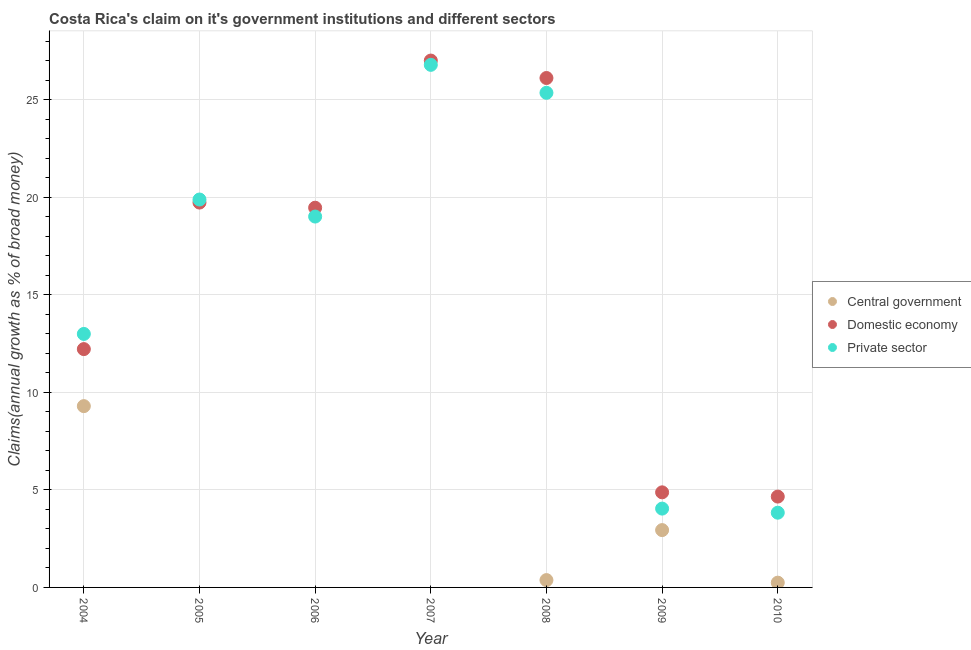How many different coloured dotlines are there?
Ensure brevity in your answer.  3. Is the number of dotlines equal to the number of legend labels?
Provide a succinct answer. No. Across all years, what is the maximum percentage of claim on the private sector?
Offer a terse response. 26.8. Across all years, what is the minimum percentage of claim on the private sector?
Keep it short and to the point. 3.83. What is the total percentage of claim on the central government in the graph?
Offer a very short reply. 12.86. What is the difference between the percentage of claim on the domestic economy in 2005 and that in 2010?
Provide a succinct answer. 15.08. What is the difference between the percentage of claim on the domestic economy in 2006 and the percentage of claim on the central government in 2009?
Provide a succinct answer. 16.53. What is the average percentage of claim on the central government per year?
Provide a succinct answer. 1.84. In the year 2004, what is the difference between the percentage of claim on the central government and percentage of claim on the private sector?
Offer a very short reply. -3.7. In how many years, is the percentage of claim on the domestic economy greater than 14 %?
Provide a succinct answer. 4. What is the ratio of the percentage of claim on the private sector in 2009 to that in 2010?
Give a very brief answer. 1.05. Is the percentage of claim on the domestic economy in 2008 less than that in 2009?
Offer a terse response. No. Is the difference between the percentage of claim on the private sector in 2004 and 2009 greater than the difference between the percentage of claim on the central government in 2004 and 2009?
Your response must be concise. Yes. What is the difference between the highest and the second highest percentage of claim on the private sector?
Give a very brief answer. 1.43. What is the difference between the highest and the lowest percentage of claim on the domestic economy?
Keep it short and to the point. 22.36. In how many years, is the percentage of claim on the private sector greater than the average percentage of claim on the private sector taken over all years?
Make the answer very short. 4. Is the sum of the percentage of claim on the central government in 2008 and 2010 greater than the maximum percentage of claim on the domestic economy across all years?
Ensure brevity in your answer.  No. Is the percentage of claim on the private sector strictly less than the percentage of claim on the domestic economy over the years?
Provide a succinct answer. No. Are the values on the major ticks of Y-axis written in scientific E-notation?
Your answer should be very brief. No. Does the graph contain any zero values?
Your response must be concise. Yes. Where does the legend appear in the graph?
Give a very brief answer. Center right. What is the title of the graph?
Provide a succinct answer. Costa Rica's claim on it's government institutions and different sectors. Does "Fuel" appear as one of the legend labels in the graph?
Your response must be concise. No. What is the label or title of the X-axis?
Your answer should be compact. Year. What is the label or title of the Y-axis?
Ensure brevity in your answer.  Claims(annual growth as % of broad money). What is the Claims(annual growth as % of broad money) of Central government in 2004?
Ensure brevity in your answer.  9.3. What is the Claims(annual growth as % of broad money) in Domestic economy in 2004?
Your response must be concise. 12.22. What is the Claims(annual growth as % of broad money) of Private sector in 2004?
Make the answer very short. 13. What is the Claims(annual growth as % of broad money) in Central government in 2005?
Make the answer very short. 0. What is the Claims(annual growth as % of broad money) in Domestic economy in 2005?
Your response must be concise. 19.73. What is the Claims(annual growth as % of broad money) of Private sector in 2005?
Keep it short and to the point. 19.89. What is the Claims(annual growth as % of broad money) in Domestic economy in 2006?
Provide a succinct answer. 19.47. What is the Claims(annual growth as % of broad money) in Private sector in 2006?
Keep it short and to the point. 19.02. What is the Claims(annual growth as % of broad money) of Central government in 2007?
Provide a succinct answer. 0. What is the Claims(annual growth as % of broad money) in Domestic economy in 2007?
Provide a succinct answer. 27.02. What is the Claims(annual growth as % of broad money) of Private sector in 2007?
Keep it short and to the point. 26.8. What is the Claims(annual growth as % of broad money) of Central government in 2008?
Keep it short and to the point. 0.38. What is the Claims(annual growth as % of broad money) in Domestic economy in 2008?
Your answer should be compact. 26.12. What is the Claims(annual growth as % of broad money) in Private sector in 2008?
Your response must be concise. 25.36. What is the Claims(annual growth as % of broad money) in Central government in 2009?
Keep it short and to the point. 2.94. What is the Claims(annual growth as % of broad money) of Domestic economy in 2009?
Offer a very short reply. 4.88. What is the Claims(annual growth as % of broad money) of Private sector in 2009?
Offer a very short reply. 4.04. What is the Claims(annual growth as % of broad money) of Central government in 2010?
Offer a terse response. 0.24. What is the Claims(annual growth as % of broad money) in Domestic economy in 2010?
Your answer should be very brief. 4.66. What is the Claims(annual growth as % of broad money) of Private sector in 2010?
Give a very brief answer. 3.83. Across all years, what is the maximum Claims(annual growth as % of broad money) of Central government?
Keep it short and to the point. 9.3. Across all years, what is the maximum Claims(annual growth as % of broad money) in Domestic economy?
Keep it short and to the point. 27.02. Across all years, what is the maximum Claims(annual growth as % of broad money) of Private sector?
Offer a very short reply. 26.8. Across all years, what is the minimum Claims(annual growth as % of broad money) in Domestic economy?
Your answer should be very brief. 4.66. Across all years, what is the minimum Claims(annual growth as % of broad money) in Private sector?
Provide a succinct answer. 3.83. What is the total Claims(annual growth as % of broad money) of Central government in the graph?
Your answer should be very brief. 12.86. What is the total Claims(annual growth as % of broad money) of Domestic economy in the graph?
Offer a very short reply. 114.09. What is the total Claims(annual growth as % of broad money) of Private sector in the graph?
Offer a terse response. 111.94. What is the difference between the Claims(annual growth as % of broad money) of Domestic economy in 2004 and that in 2005?
Make the answer very short. -7.51. What is the difference between the Claims(annual growth as % of broad money) of Private sector in 2004 and that in 2005?
Provide a succinct answer. -6.89. What is the difference between the Claims(annual growth as % of broad money) of Domestic economy in 2004 and that in 2006?
Offer a very short reply. -7.25. What is the difference between the Claims(annual growth as % of broad money) of Private sector in 2004 and that in 2006?
Offer a very short reply. -6.02. What is the difference between the Claims(annual growth as % of broad money) in Domestic economy in 2004 and that in 2007?
Your answer should be very brief. -14.8. What is the difference between the Claims(annual growth as % of broad money) in Private sector in 2004 and that in 2007?
Ensure brevity in your answer.  -13.8. What is the difference between the Claims(annual growth as % of broad money) of Central government in 2004 and that in 2008?
Offer a terse response. 8.92. What is the difference between the Claims(annual growth as % of broad money) in Domestic economy in 2004 and that in 2008?
Offer a very short reply. -13.9. What is the difference between the Claims(annual growth as % of broad money) in Private sector in 2004 and that in 2008?
Make the answer very short. -12.36. What is the difference between the Claims(annual growth as % of broad money) in Central government in 2004 and that in 2009?
Your answer should be very brief. 6.36. What is the difference between the Claims(annual growth as % of broad money) in Domestic economy in 2004 and that in 2009?
Give a very brief answer. 7.34. What is the difference between the Claims(annual growth as % of broad money) in Private sector in 2004 and that in 2009?
Provide a short and direct response. 8.96. What is the difference between the Claims(annual growth as % of broad money) in Central government in 2004 and that in 2010?
Your answer should be very brief. 9.05. What is the difference between the Claims(annual growth as % of broad money) of Domestic economy in 2004 and that in 2010?
Give a very brief answer. 7.56. What is the difference between the Claims(annual growth as % of broad money) of Private sector in 2004 and that in 2010?
Ensure brevity in your answer.  9.17. What is the difference between the Claims(annual growth as % of broad money) of Domestic economy in 2005 and that in 2006?
Provide a short and direct response. 0.26. What is the difference between the Claims(annual growth as % of broad money) of Private sector in 2005 and that in 2006?
Provide a succinct answer. 0.87. What is the difference between the Claims(annual growth as % of broad money) of Domestic economy in 2005 and that in 2007?
Offer a very short reply. -7.28. What is the difference between the Claims(annual growth as % of broad money) in Private sector in 2005 and that in 2007?
Offer a very short reply. -6.9. What is the difference between the Claims(annual growth as % of broad money) in Domestic economy in 2005 and that in 2008?
Offer a terse response. -6.39. What is the difference between the Claims(annual growth as % of broad money) of Private sector in 2005 and that in 2008?
Your answer should be very brief. -5.47. What is the difference between the Claims(annual growth as % of broad money) of Domestic economy in 2005 and that in 2009?
Give a very brief answer. 14.86. What is the difference between the Claims(annual growth as % of broad money) of Private sector in 2005 and that in 2009?
Make the answer very short. 15.85. What is the difference between the Claims(annual growth as % of broad money) in Domestic economy in 2005 and that in 2010?
Keep it short and to the point. 15.08. What is the difference between the Claims(annual growth as % of broad money) of Private sector in 2005 and that in 2010?
Ensure brevity in your answer.  16.06. What is the difference between the Claims(annual growth as % of broad money) of Domestic economy in 2006 and that in 2007?
Offer a very short reply. -7.55. What is the difference between the Claims(annual growth as % of broad money) in Private sector in 2006 and that in 2007?
Offer a very short reply. -7.78. What is the difference between the Claims(annual growth as % of broad money) of Domestic economy in 2006 and that in 2008?
Give a very brief answer. -6.65. What is the difference between the Claims(annual growth as % of broad money) of Private sector in 2006 and that in 2008?
Give a very brief answer. -6.34. What is the difference between the Claims(annual growth as % of broad money) in Domestic economy in 2006 and that in 2009?
Your answer should be very brief. 14.59. What is the difference between the Claims(annual growth as % of broad money) in Private sector in 2006 and that in 2009?
Your response must be concise. 14.97. What is the difference between the Claims(annual growth as % of broad money) of Domestic economy in 2006 and that in 2010?
Provide a succinct answer. 14.81. What is the difference between the Claims(annual growth as % of broad money) in Private sector in 2006 and that in 2010?
Keep it short and to the point. 15.18. What is the difference between the Claims(annual growth as % of broad money) in Domestic economy in 2007 and that in 2008?
Make the answer very short. 0.89. What is the difference between the Claims(annual growth as % of broad money) in Private sector in 2007 and that in 2008?
Keep it short and to the point. 1.43. What is the difference between the Claims(annual growth as % of broad money) of Domestic economy in 2007 and that in 2009?
Offer a terse response. 22.14. What is the difference between the Claims(annual growth as % of broad money) in Private sector in 2007 and that in 2009?
Keep it short and to the point. 22.75. What is the difference between the Claims(annual growth as % of broad money) of Domestic economy in 2007 and that in 2010?
Make the answer very short. 22.36. What is the difference between the Claims(annual growth as % of broad money) in Private sector in 2007 and that in 2010?
Keep it short and to the point. 22.96. What is the difference between the Claims(annual growth as % of broad money) of Central government in 2008 and that in 2009?
Ensure brevity in your answer.  -2.56. What is the difference between the Claims(annual growth as % of broad money) in Domestic economy in 2008 and that in 2009?
Keep it short and to the point. 21.25. What is the difference between the Claims(annual growth as % of broad money) of Private sector in 2008 and that in 2009?
Your answer should be very brief. 21.32. What is the difference between the Claims(annual growth as % of broad money) of Central government in 2008 and that in 2010?
Offer a very short reply. 0.13. What is the difference between the Claims(annual growth as % of broad money) of Domestic economy in 2008 and that in 2010?
Your response must be concise. 21.46. What is the difference between the Claims(annual growth as % of broad money) of Private sector in 2008 and that in 2010?
Offer a very short reply. 21.53. What is the difference between the Claims(annual growth as % of broad money) of Central government in 2009 and that in 2010?
Give a very brief answer. 2.7. What is the difference between the Claims(annual growth as % of broad money) of Domestic economy in 2009 and that in 2010?
Provide a short and direct response. 0.22. What is the difference between the Claims(annual growth as % of broad money) of Private sector in 2009 and that in 2010?
Your answer should be compact. 0.21. What is the difference between the Claims(annual growth as % of broad money) in Central government in 2004 and the Claims(annual growth as % of broad money) in Domestic economy in 2005?
Your answer should be very brief. -10.44. What is the difference between the Claims(annual growth as % of broad money) in Central government in 2004 and the Claims(annual growth as % of broad money) in Private sector in 2005?
Keep it short and to the point. -10.59. What is the difference between the Claims(annual growth as % of broad money) of Domestic economy in 2004 and the Claims(annual growth as % of broad money) of Private sector in 2005?
Keep it short and to the point. -7.67. What is the difference between the Claims(annual growth as % of broad money) of Central government in 2004 and the Claims(annual growth as % of broad money) of Domestic economy in 2006?
Give a very brief answer. -10.17. What is the difference between the Claims(annual growth as % of broad money) in Central government in 2004 and the Claims(annual growth as % of broad money) in Private sector in 2006?
Offer a very short reply. -9.72. What is the difference between the Claims(annual growth as % of broad money) of Domestic economy in 2004 and the Claims(annual growth as % of broad money) of Private sector in 2006?
Offer a very short reply. -6.8. What is the difference between the Claims(annual growth as % of broad money) in Central government in 2004 and the Claims(annual growth as % of broad money) in Domestic economy in 2007?
Make the answer very short. -17.72. What is the difference between the Claims(annual growth as % of broad money) in Central government in 2004 and the Claims(annual growth as % of broad money) in Private sector in 2007?
Your answer should be compact. -17.5. What is the difference between the Claims(annual growth as % of broad money) in Domestic economy in 2004 and the Claims(annual growth as % of broad money) in Private sector in 2007?
Keep it short and to the point. -14.58. What is the difference between the Claims(annual growth as % of broad money) in Central government in 2004 and the Claims(annual growth as % of broad money) in Domestic economy in 2008?
Provide a succinct answer. -16.82. What is the difference between the Claims(annual growth as % of broad money) of Central government in 2004 and the Claims(annual growth as % of broad money) of Private sector in 2008?
Your answer should be very brief. -16.07. What is the difference between the Claims(annual growth as % of broad money) of Domestic economy in 2004 and the Claims(annual growth as % of broad money) of Private sector in 2008?
Your answer should be compact. -13.14. What is the difference between the Claims(annual growth as % of broad money) in Central government in 2004 and the Claims(annual growth as % of broad money) in Domestic economy in 2009?
Provide a succinct answer. 4.42. What is the difference between the Claims(annual growth as % of broad money) in Central government in 2004 and the Claims(annual growth as % of broad money) in Private sector in 2009?
Offer a terse response. 5.25. What is the difference between the Claims(annual growth as % of broad money) in Domestic economy in 2004 and the Claims(annual growth as % of broad money) in Private sector in 2009?
Give a very brief answer. 8.18. What is the difference between the Claims(annual growth as % of broad money) in Central government in 2004 and the Claims(annual growth as % of broad money) in Domestic economy in 2010?
Keep it short and to the point. 4.64. What is the difference between the Claims(annual growth as % of broad money) in Central government in 2004 and the Claims(annual growth as % of broad money) in Private sector in 2010?
Keep it short and to the point. 5.46. What is the difference between the Claims(annual growth as % of broad money) of Domestic economy in 2004 and the Claims(annual growth as % of broad money) of Private sector in 2010?
Your answer should be compact. 8.39. What is the difference between the Claims(annual growth as % of broad money) in Domestic economy in 2005 and the Claims(annual growth as % of broad money) in Private sector in 2006?
Make the answer very short. 0.72. What is the difference between the Claims(annual growth as % of broad money) in Domestic economy in 2005 and the Claims(annual growth as % of broad money) in Private sector in 2007?
Give a very brief answer. -7.06. What is the difference between the Claims(annual growth as % of broad money) in Domestic economy in 2005 and the Claims(annual growth as % of broad money) in Private sector in 2008?
Provide a short and direct response. -5.63. What is the difference between the Claims(annual growth as % of broad money) in Domestic economy in 2005 and the Claims(annual growth as % of broad money) in Private sector in 2009?
Give a very brief answer. 15.69. What is the difference between the Claims(annual growth as % of broad money) of Domestic economy in 2005 and the Claims(annual growth as % of broad money) of Private sector in 2010?
Provide a succinct answer. 15.9. What is the difference between the Claims(annual growth as % of broad money) of Domestic economy in 2006 and the Claims(annual growth as % of broad money) of Private sector in 2007?
Offer a very short reply. -7.33. What is the difference between the Claims(annual growth as % of broad money) of Domestic economy in 2006 and the Claims(annual growth as % of broad money) of Private sector in 2008?
Make the answer very short. -5.89. What is the difference between the Claims(annual growth as % of broad money) of Domestic economy in 2006 and the Claims(annual growth as % of broad money) of Private sector in 2009?
Offer a very short reply. 15.43. What is the difference between the Claims(annual growth as % of broad money) in Domestic economy in 2006 and the Claims(annual growth as % of broad money) in Private sector in 2010?
Provide a short and direct response. 15.64. What is the difference between the Claims(annual growth as % of broad money) in Domestic economy in 2007 and the Claims(annual growth as % of broad money) in Private sector in 2008?
Keep it short and to the point. 1.65. What is the difference between the Claims(annual growth as % of broad money) of Domestic economy in 2007 and the Claims(annual growth as % of broad money) of Private sector in 2009?
Ensure brevity in your answer.  22.97. What is the difference between the Claims(annual growth as % of broad money) of Domestic economy in 2007 and the Claims(annual growth as % of broad money) of Private sector in 2010?
Provide a short and direct response. 23.18. What is the difference between the Claims(annual growth as % of broad money) of Central government in 2008 and the Claims(annual growth as % of broad money) of Domestic economy in 2009?
Your response must be concise. -4.5. What is the difference between the Claims(annual growth as % of broad money) in Central government in 2008 and the Claims(annual growth as % of broad money) in Private sector in 2009?
Ensure brevity in your answer.  -3.67. What is the difference between the Claims(annual growth as % of broad money) of Domestic economy in 2008 and the Claims(annual growth as % of broad money) of Private sector in 2009?
Your answer should be very brief. 22.08. What is the difference between the Claims(annual growth as % of broad money) of Central government in 2008 and the Claims(annual growth as % of broad money) of Domestic economy in 2010?
Your answer should be very brief. -4.28. What is the difference between the Claims(annual growth as % of broad money) in Central government in 2008 and the Claims(annual growth as % of broad money) in Private sector in 2010?
Make the answer very short. -3.46. What is the difference between the Claims(annual growth as % of broad money) of Domestic economy in 2008 and the Claims(annual growth as % of broad money) of Private sector in 2010?
Give a very brief answer. 22.29. What is the difference between the Claims(annual growth as % of broad money) of Central government in 2009 and the Claims(annual growth as % of broad money) of Domestic economy in 2010?
Your answer should be very brief. -1.72. What is the difference between the Claims(annual growth as % of broad money) of Central government in 2009 and the Claims(annual growth as % of broad money) of Private sector in 2010?
Keep it short and to the point. -0.89. What is the difference between the Claims(annual growth as % of broad money) in Domestic economy in 2009 and the Claims(annual growth as % of broad money) in Private sector in 2010?
Offer a terse response. 1.04. What is the average Claims(annual growth as % of broad money) of Central government per year?
Make the answer very short. 1.84. What is the average Claims(annual growth as % of broad money) in Domestic economy per year?
Make the answer very short. 16.3. What is the average Claims(annual growth as % of broad money) of Private sector per year?
Your answer should be compact. 15.99. In the year 2004, what is the difference between the Claims(annual growth as % of broad money) in Central government and Claims(annual growth as % of broad money) in Domestic economy?
Keep it short and to the point. -2.92. In the year 2004, what is the difference between the Claims(annual growth as % of broad money) in Central government and Claims(annual growth as % of broad money) in Private sector?
Ensure brevity in your answer.  -3.7. In the year 2004, what is the difference between the Claims(annual growth as % of broad money) of Domestic economy and Claims(annual growth as % of broad money) of Private sector?
Give a very brief answer. -0.78. In the year 2005, what is the difference between the Claims(annual growth as % of broad money) in Domestic economy and Claims(annual growth as % of broad money) in Private sector?
Keep it short and to the point. -0.16. In the year 2006, what is the difference between the Claims(annual growth as % of broad money) of Domestic economy and Claims(annual growth as % of broad money) of Private sector?
Your response must be concise. 0.45. In the year 2007, what is the difference between the Claims(annual growth as % of broad money) in Domestic economy and Claims(annual growth as % of broad money) in Private sector?
Ensure brevity in your answer.  0.22. In the year 2008, what is the difference between the Claims(annual growth as % of broad money) of Central government and Claims(annual growth as % of broad money) of Domestic economy?
Ensure brevity in your answer.  -25.75. In the year 2008, what is the difference between the Claims(annual growth as % of broad money) in Central government and Claims(annual growth as % of broad money) in Private sector?
Your response must be concise. -24.99. In the year 2008, what is the difference between the Claims(annual growth as % of broad money) in Domestic economy and Claims(annual growth as % of broad money) in Private sector?
Your answer should be compact. 0.76. In the year 2009, what is the difference between the Claims(annual growth as % of broad money) of Central government and Claims(annual growth as % of broad money) of Domestic economy?
Ensure brevity in your answer.  -1.94. In the year 2009, what is the difference between the Claims(annual growth as % of broad money) of Central government and Claims(annual growth as % of broad money) of Private sector?
Provide a succinct answer. -1.1. In the year 2009, what is the difference between the Claims(annual growth as % of broad money) of Domestic economy and Claims(annual growth as % of broad money) of Private sector?
Offer a very short reply. 0.83. In the year 2010, what is the difference between the Claims(annual growth as % of broad money) in Central government and Claims(annual growth as % of broad money) in Domestic economy?
Ensure brevity in your answer.  -4.41. In the year 2010, what is the difference between the Claims(annual growth as % of broad money) of Central government and Claims(annual growth as % of broad money) of Private sector?
Give a very brief answer. -3.59. In the year 2010, what is the difference between the Claims(annual growth as % of broad money) of Domestic economy and Claims(annual growth as % of broad money) of Private sector?
Make the answer very short. 0.83. What is the ratio of the Claims(annual growth as % of broad money) in Domestic economy in 2004 to that in 2005?
Ensure brevity in your answer.  0.62. What is the ratio of the Claims(annual growth as % of broad money) in Private sector in 2004 to that in 2005?
Provide a short and direct response. 0.65. What is the ratio of the Claims(annual growth as % of broad money) of Domestic economy in 2004 to that in 2006?
Give a very brief answer. 0.63. What is the ratio of the Claims(annual growth as % of broad money) in Private sector in 2004 to that in 2006?
Provide a succinct answer. 0.68. What is the ratio of the Claims(annual growth as % of broad money) in Domestic economy in 2004 to that in 2007?
Keep it short and to the point. 0.45. What is the ratio of the Claims(annual growth as % of broad money) of Private sector in 2004 to that in 2007?
Your answer should be compact. 0.49. What is the ratio of the Claims(annual growth as % of broad money) in Central government in 2004 to that in 2008?
Provide a succinct answer. 24.74. What is the ratio of the Claims(annual growth as % of broad money) in Domestic economy in 2004 to that in 2008?
Keep it short and to the point. 0.47. What is the ratio of the Claims(annual growth as % of broad money) in Private sector in 2004 to that in 2008?
Give a very brief answer. 0.51. What is the ratio of the Claims(annual growth as % of broad money) in Central government in 2004 to that in 2009?
Provide a short and direct response. 3.16. What is the ratio of the Claims(annual growth as % of broad money) in Domestic economy in 2004 to that in 2009?
Your answer should be compact. 2.51. What is the ratio of the Claims(annual growth as % of broad money) of Private sector in 2004 to that in 2009?
Offer a very short reply. 3.22. What is the ratio of the Claims(annual growth as % of broad money) of Central government in 2004 to that in 2010?
Your answer should be very brief. 38.01. What is the ratio of the Claims(annual growth as % of broad money) of Domestic economy in 2004 to that in 2010?
Your answer should be compact. 2.62. What is the ratio of the Claims(annual growth as % of broad money) in Private sector in 2004 to that in 2010?
Your answer should be very brief. 3.39. What is the ratio of the Claims(annual growth as % of broad money) in Domestic economy in 2005 to that in 2006?
Provide a short and direct response. 1.01. What is the ratio of the Claims(annual growth as % of broad money) of Private sector in 2005 to that in 2006?
Your answer should be very brief. 1.05. What is the ratio of the Claims(annual growth as % of broad money) in Domestic economy in 2005 to that in 2007?
Ensure brevity in your answer.  0.73. What is the ratio of the Claims(annual growth as % of broad money) in Private sector in 2005 to that in 2007?
Offer a very short reply. 0.74. What is the ratio of the Claims(annual growth as % of broad money) in Domestic economy in 2005 to that in 2008?
Your response must be concise. 0.76. What is the ratio of the Claims(annual growth as % of broad money) of Private sector in 2005 to that in 2008?
Make the answer very short. 0.78. What is the ratio of the Claims(annual growth as % of broad money) of Domestic economy in 2005 to that in 2009?
Make the answer very short. 4.05. What is the ratio of the Claims(annual growth as % of broad money) of Private sector in 2005 to that in 2009?
Keep it short and to the point. 4.92. What is the ratio of the Claims(annual growth as % of broad money) of Domestic economy in 2005 to that in 2010?
Provide a succinct answer. 4.24. What is the ratio of the Claims(annual growth as % of broad money) of Private sector in 2005 to that in 2010?
Your answer should be very brief. 5.19. What is the ratio of the Claims(annual growth as % of broad money) of Domestic economy in 2006 to that in 2007?
Give a very brief answer. 0.72. What is the ratio of the Claims(annual growth as % of broad money) of Private sector in 2006 to that in 2007?
Give a very brief answer. 0.71. What is the ratio of the Claims(annual growth as % of broad money) of Domestic economy in 2006 to that in 2008?
Provide a short and direct response. 0.75. What is the ratio of the Claims(annual growth as % of broad money) in Private sector in 2006 to that in 2008?
Offer a terse response. 0.75. What is the ratio of the Claims(annual growth as % of broad money) of Domestic economy in 2006 to that in 2009?
Make the answer very short. 3.99. What is the ratio of the Claims(annual growth as % of broad money) in Private sector in 2006 to that in 2009?
Your answer should be compact. 4.71. What is the ratio of the Claims(annual growth as % of broad money) of Domestic economy in 2006 to that in 2010?
Ensure brevity in your answer.  4.18. What is the ratio of the Claims(annual growth as % of broad money) in Private sector in 2006 to that in 2010?
Keep it short and to the point. 4.96. What is the ratio of the Claims(annual growth as % of broad money) in Domestic economy in 2007 to that in 2008?
Ensure brevity in your answer.  1.03. What is the ratio of the Claims(annual growth as % of broad money) of Private sector in 2007 to that in 2008?
Provide a succinct answer. 1.06. What is the ratio of the Claims(annual growth as % of broad money) of Domestic economy in 2007 to that in 2009?
Ensure brevity in your answer.  5.54. What is the ratio of the Claims(annual growth as % of broad money) of Private sector in 2007 to that in 2009?
Your answer should be compact. 6.63. What is the ratio of the Claims(annual growth as % of broad money) in Domestic economy in 2007 to that in 2010?
Ensure brevity in your answer.  5.8. What is the ratio of the Claims(annual growth as % of broad money) in Private sector in 2007 to that in 2010?
Make the answer very short. 6.99. What is the ratio of the Claims(annual growth as % of broad money) in Central government in 2008 to that in 2009?
Your answer should be very brief. 0.13. What is the ratio of the Claims(annual growth as % of broad money) in Domestic economy in 2008 to that in 2009?
Make the answer very short. 5.36. What is the ratio of the Claims(annual growth as % of broad money) in Private sector in 2008 to that in 2009?
Offer a very short reply. 6.28. What is the ratio of the Claims(annual growth as % of broad money) of Central government in 2008 to that in 2010?
Your answer should be compact. 1.54. What is the ratio of the Claims(annual growth as % of broad money) in Domestic economy in 2008 to that in 2010?
Ensure brevity in your answer.  5.61. What is the ratio of the Claims(annual growth as % of broad money) in Private sector in 2008 to that in 2010?
Offer a terse response. 6.62. What is the ratio of the Claims(annual growth as % of broad money) in Central government in 2009 to that in 2010?
Provide a short and direct response. 12.02. What is the ratio of the Claims(annual growth as % of broad money) of Domestic economy in 2009 to that in 2010?
Provide a short and direct response. 1.05. What is the ratio of the Claims(annual growth as % of broad money) in Private sector in 2009 to that in 2010?
Give a very brief answer. 1.05. What is the difference between the highest and the second highest Claims(annual growth as % of broad money) in Central government?
Offer a terse response. 6.36. What is the difference between the highest and the second highest Claims(annual growth as % of broad money) of Domestic economy?
Offer a very short reply. 0.89. What is the difference between the highest and the second highest Claims(annual growth as % of broad money) of Private sector?
Keep it short and to the point. 1.43. What is the difference between the highest and the lowest Claims(annual growth as % of broad money) in Central government?
Keep it short and to the point. 9.3. What is the difference between the highest and the lowest Claims(annual growth as % of broad money) in Domestic economy?
Make the answer very short. 22.36. What is the difference between the highest and the lowest Claims(annual growth as % of broad money) in Private sector?
Offer a very short reply. 22.96. 